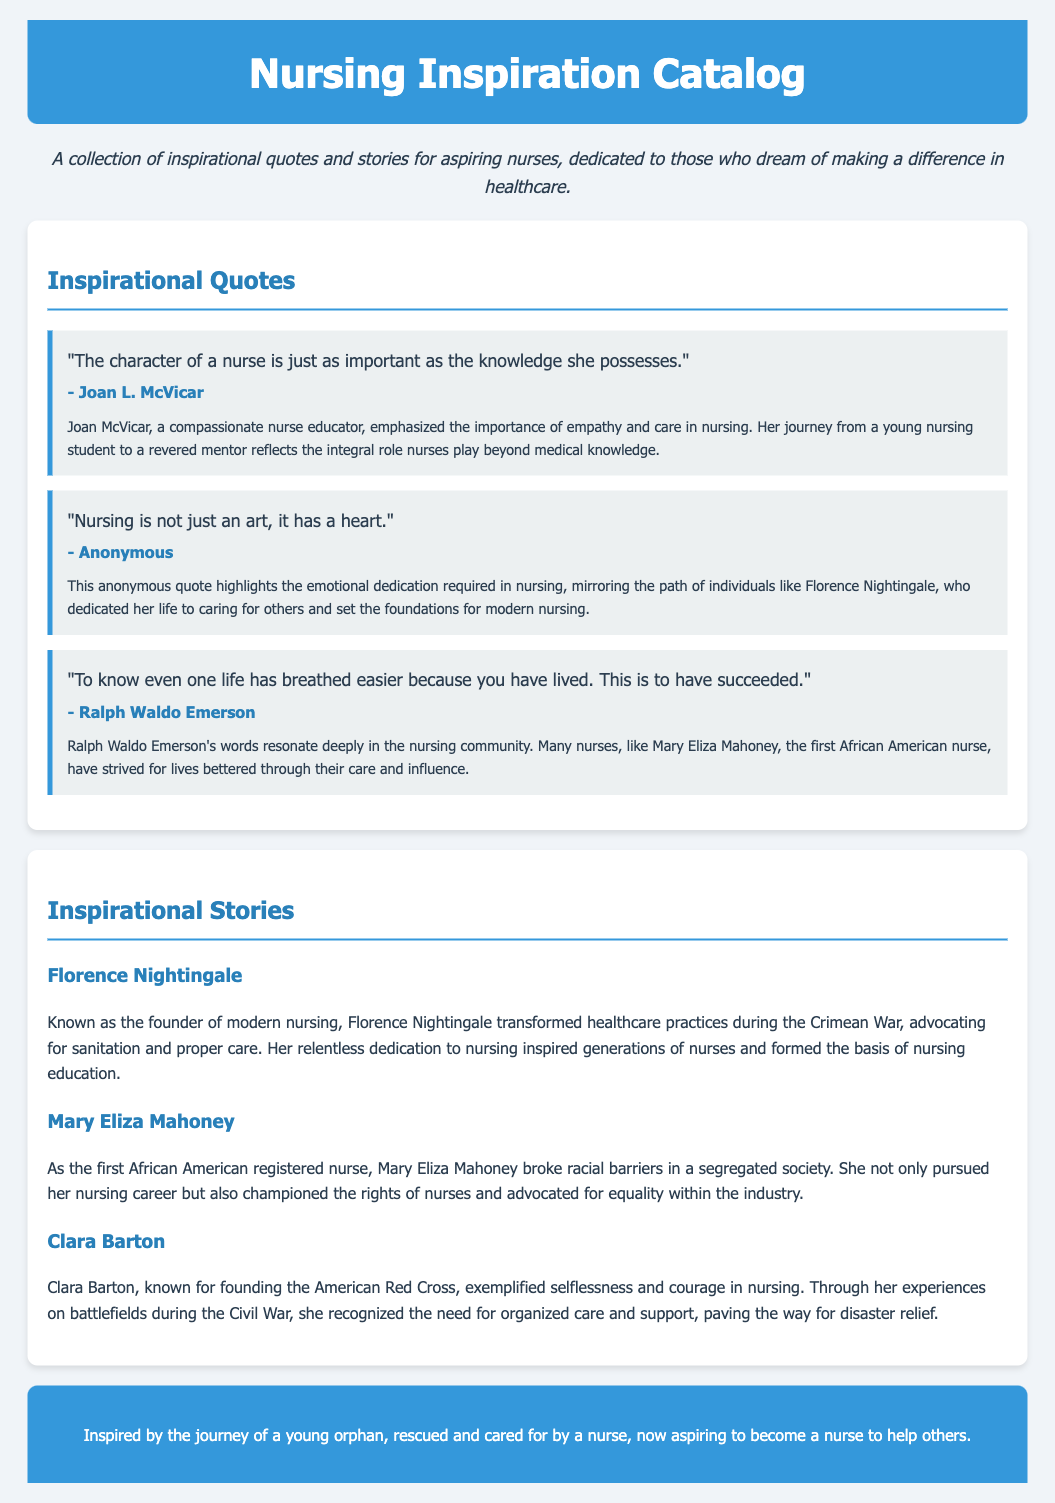What is the title of the document? The title of the document is stated in the header section, which is "Nursing Inspiration Catalog."
Answer: Nursing Inspiration Catalog Who is quoted as saying, "The character of a nurse is just as important as the knowledge she possesses"? This quote is attributed to Joan L. McVicar, who is mentioned right after the quote.
Answer: Joan L. McVicar How many inspirational quotes are listed in the document? There are three quotes presented in the section dedicated to inspirational quotes, as indicated by the count of quote blocks.
Answer: Three What significant contribution is Florence Nightingale known for? Florence Nightingale is known for transforming healthcare practices during the Crimean War, as mentioned in her story.
Answer: Founder of modern nursing Which historical figure is recognized as the first African American registered nurse? The document specifically mentions Mary Eliza Mahoney as the first African American registered nurse in her story.
Answer: Mary Eliza Mahoney What is the main theme of the document? The document is a collection of inspirational quotes and stories aimed at aspiring nurses, emphasizing their impact in healthcare.
Answer: Inspirational quotes and stories Which organization did Clara Barton found? The document states that Clara Barton is known for founding the American Red Cross, part of her contribution in nursing.
Answer: American Red Cross What emotion does the anonymous quote highlight in nursing? The anonymous quote emphasizes the emotional dedication required in nursing, pointing towards compassion and care.
Answer: Heart 